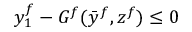Convert formula to latex. <formula><loc_0><loc_0><loc_500><loc_500>y _ { 1 } ^ { f } - G ^ { f } ( { \bar { y } } ^ { f } , z ^ { f } ) \leq 0</formula> 